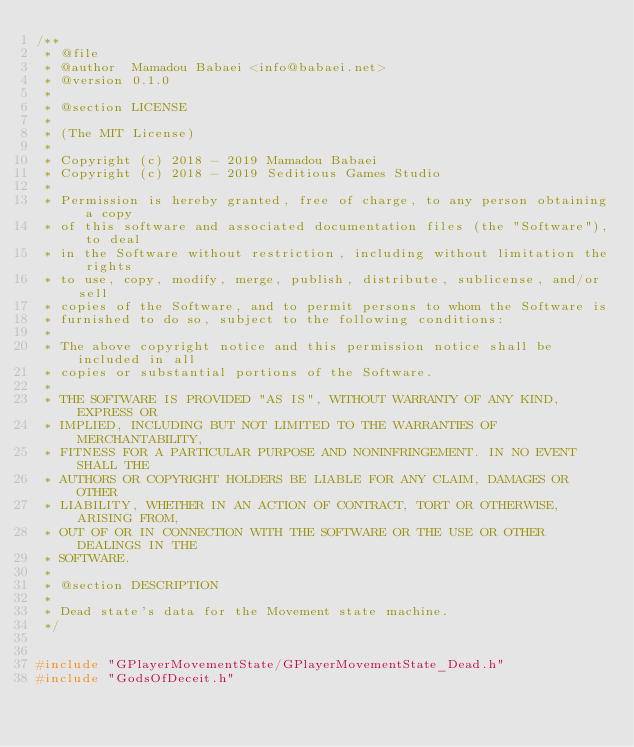<code> <loc_0><loc_0><loc_500><loc_500><_C++_>/**
 * @file
 * @author  Mamadou Babaei <info@babaei.net>
 * @version 0.1.0
 *
 * @section LICENSE
 *
 * (The MIT License)
 *
 * Copyright (c) 2018 - 2019 Mamadou Babaei
 * Copyright (c) 2018 - 2019 Seditious Games Studio
 *
 * Permission is hereby granted, free of charge, to any person obtaining a copy
 * of this software and associated documentation files (the "Software"), to deal
 * in the Software without restriction, including without limitation the rights
 * to use, copy, modify, merge, publish, distribute, sublicense, and/or sell
 * copies of the Software, and to permit persons to whom the Software is
 * furnished to do so, subject to the following conditions:
 *
 * The above copyright notice and this permission notice shall be included in all
 * copies or substantial portions of the Software.
 *
 * THE SOFTWARE IS PROVIDED "AS IS", WITHOUT WARRANTY OF ANY KIND, EXPRESS OR
 * IMPLIED, INCLUDING BUT NOT LIMITED TO THE WARRANTIES OF MERCHANTABILITY,
 * FITNESS FOR A PARTICULAR PURPOSE AND NONINFRINGEMENT. IN NO EVENT SHALL THE
 * AUTHORS OR COPYRIGHT HOLDERS BE LIABLE FOR ANY CLAIM, DAMAGES OR OTHER
 * LIABILITY, WHETHER IN AN ACTION OF CONTRACT, TORT OR OTHERWISE, ARISING FROM,
 * OUT OF OR IN CONNECTION WITH THE SOFTWARE OR THE USE OR OTHER DEALINGS IN THE
 * SOFTWARE.
 *
 * @section DESCRIPTION
 *
 * Dead state's data for the Movement state machine.
 */


#include "GPlayerMovementState/GPlayerMovementState_Dead.h"
#include "GodsOfDeceit.h"
</code> 